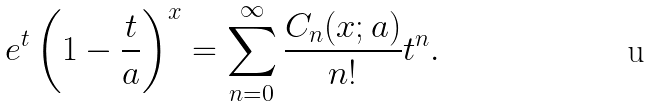Convert formula to latex. <formula><loc_0><loc_0><loc_500><loc_500>e ^ { t } \left ( 1 - \frac { t } { a } \right ) ^ { x } = \sum _ { n = 0 } ^ { \infty } \frac { C _ { n } ( x ; a ) } { n ! } t ^ { n } .</formula> 